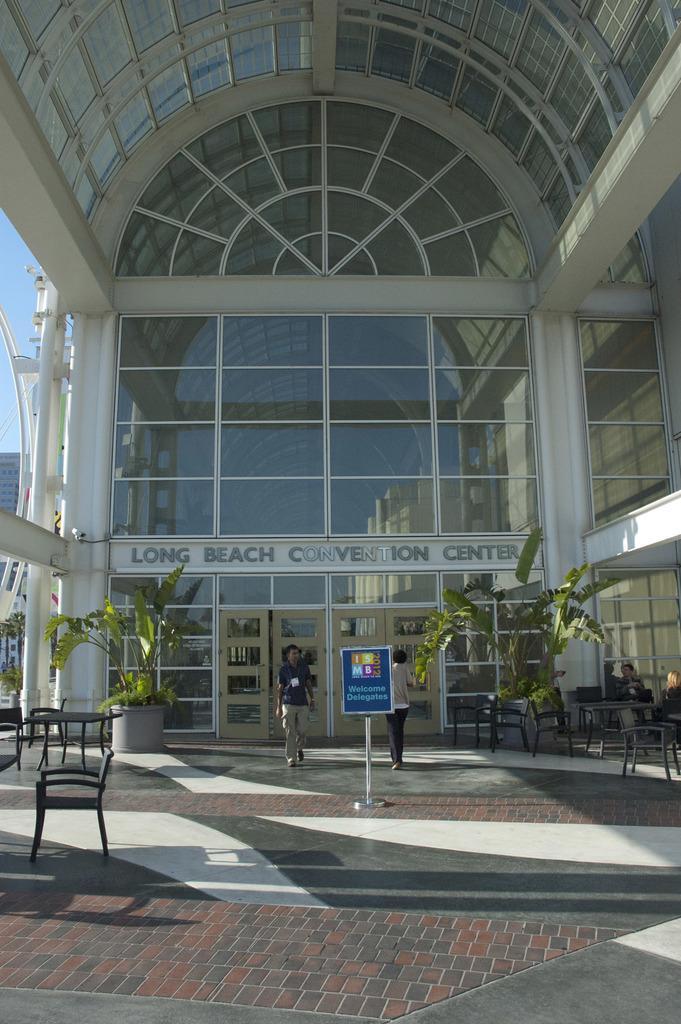Please provide a concise description of this image. In this picture we can see huge building and at entrance of building we can see man walking and here is flower pot with plant, table, chair and one more person is walking inside the building and it is a floor. 